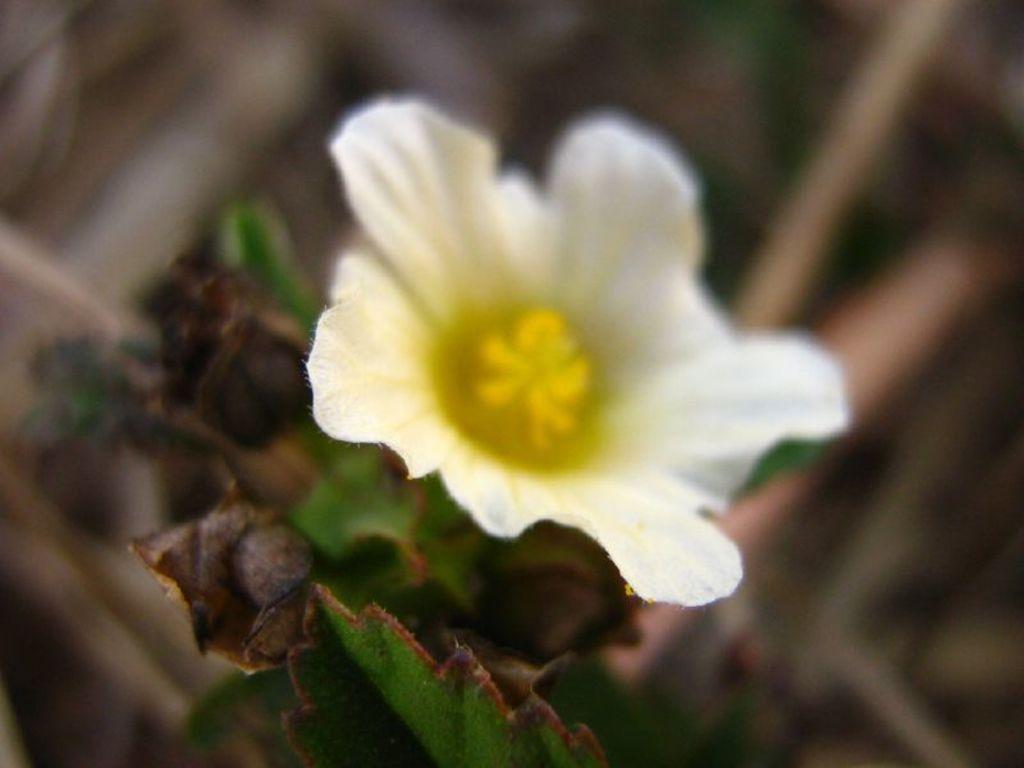In one or two sentences, can you explain what this image depicts? The image is blurred. In the image we can see leaves and a flower. The background is not clear. 